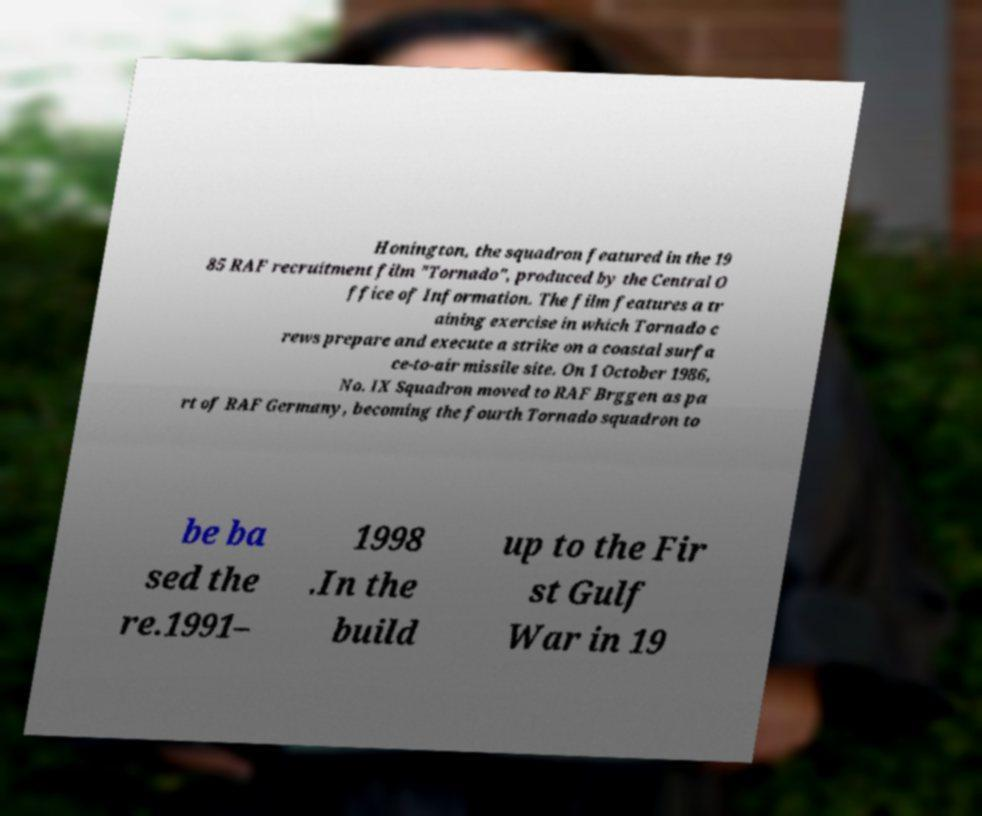Could you assist in decoding the text presented in this image and type it out clearly? Honington, the squadron featured in the 19 85 RAF recruitment film "Tornado", produced by the Central O ffice of Information. The film features a tr aining exercise in which Tornado c rews prepare and execute a strike on a coastal surfa ce-to-air missile site. On 1 October 1986, No. IX Squadron moved to RAF Brggen as pa rt of RAF Germany, becoming the fourth Tornado squadron to be ba sed the re.1991– 1998 .In the build up to the Fir st Gulf War in 19 